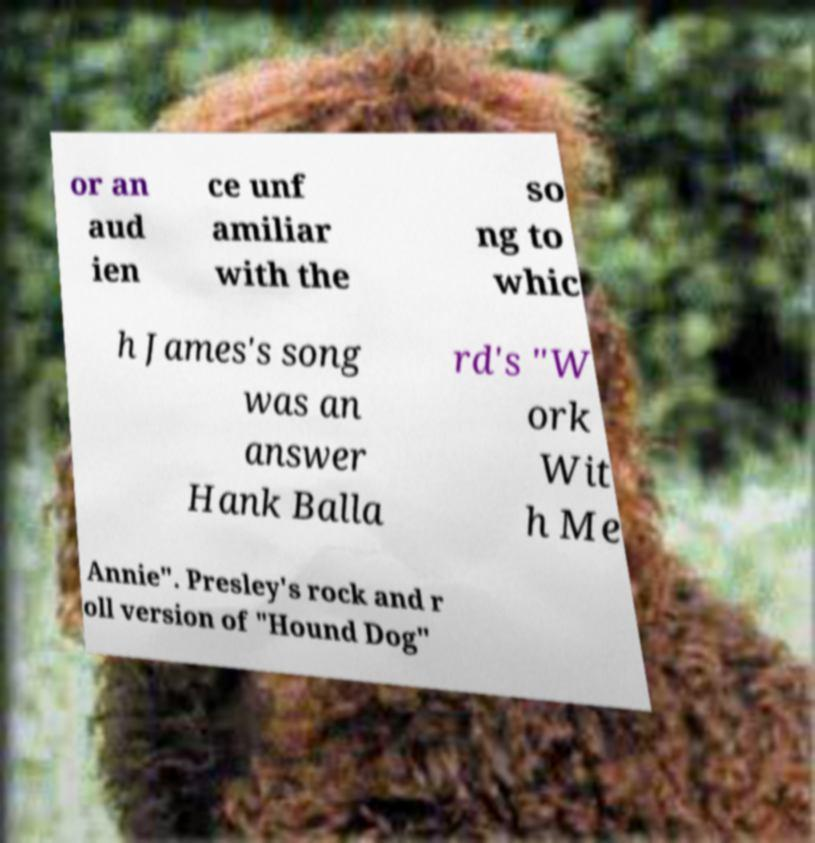What messages or text are displayed in this image? I need them in a readable, typed format. or an aud ien ce unf amiliar with the so ng to whic h James's song was an answer Hank Balla rd's "W ork Wit h Me Annie". Presley's rock and r oll version of "Hound Dog" 